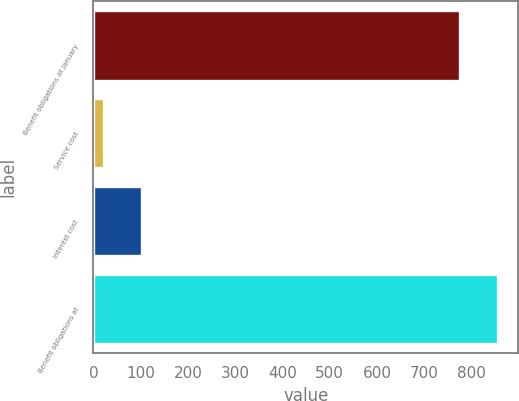<chart> <loc_0><loc_0><loc_500><loc_500><bar_chart><fcel>Benefit obligations at January<fcel>Service cost<fcel>Interest cost<fcel>Benefit obligations at<nl><fcel>776<fcel>23<fcel>102.8<fcel>855.8<nl></chart> 